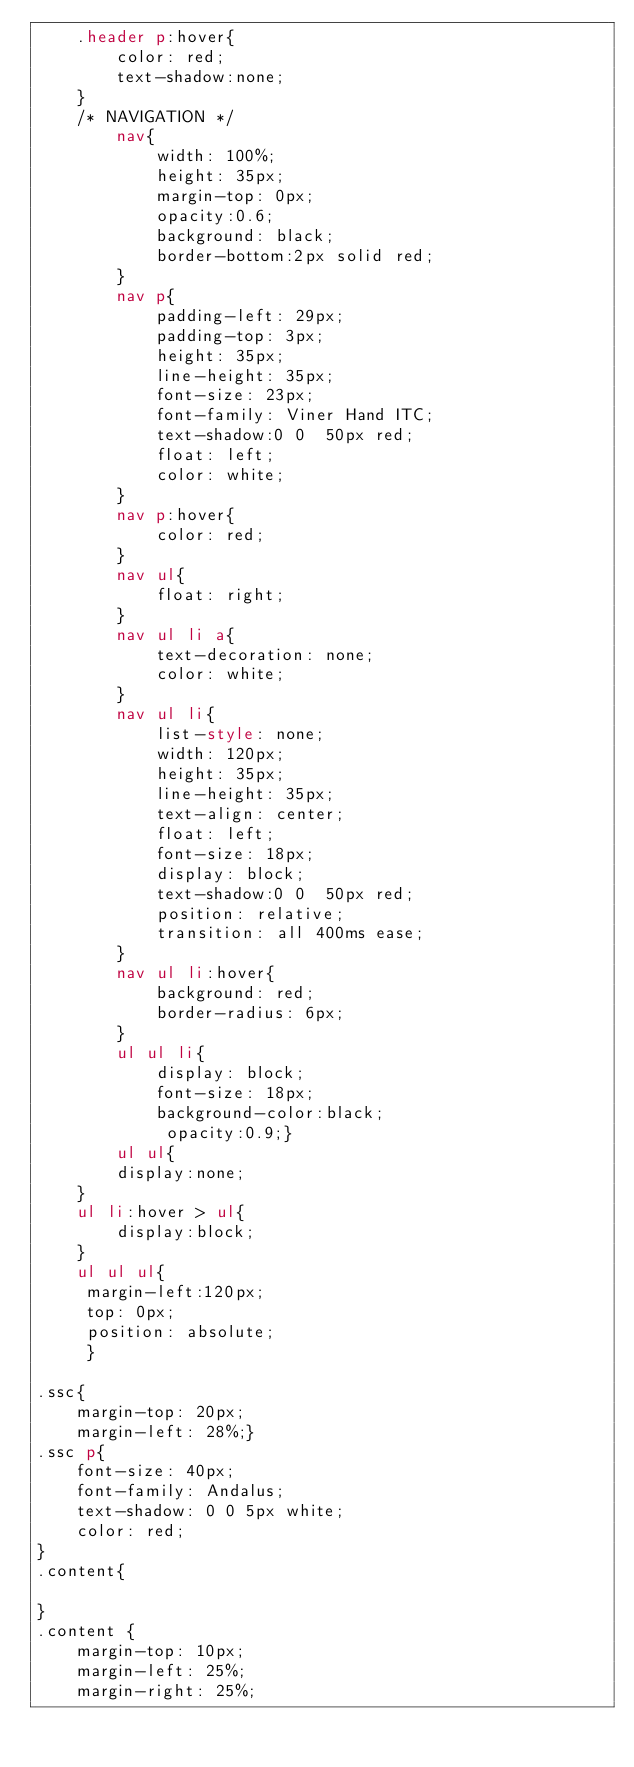<code> <loc_0><loc_0><loc_500><loc_500><_HTML_>	.header p:hover{
		color: red;
		text-shadow:none;
	}
	/* NAVIGATION */
		nav{
			width: 100%;
			height: 35px;
			margin-top: 0px;
			opacity:0.6;
			background: black;
			border-bottom:2px solid red;
		}
		nav p{
			padding-left: 29px;
			padding-top: 3px;
			height: 35px;
			line-height: 35px;
			font-size: 23px;
			font-family: Viner Hand ITC;
			text-shadow:0 0  50px red;
			float: left;
			color: white;
		}
		nav p:hover{
			color: red;
		}
		nav ul{
			float: right;
		}
		nav ul li a{
			text-decoration: none;
			color: white;
		}
		nav ul li{
			list-style: none;
			width: 120px;
			height: 35px;
			line-height: 35px;
			text-align: center;
			float: left;
			font-size: 18px;
			display: block;
			text-shadow:0 0  50px red;
			position: relative;
			transition: all 400ms ease;
		}
		nav ul li:hover{
			background: red;
			border-radius: 6px;
		}
        ul ul li{
        	display: block;
        	font-size: 18px;
        	background-color:black;
	         opacity:0.9;}
	    ul ul{
	    display:none;
	}
	ul li:hover > ul{
	    display:block;
	}
	ul ul ul{
	 margin-left:120px;
	 top: 0px;
	 position: absolute;
	 }

.ssc{
	margin-top: 20px;
	margin-left: 28%;}
.ssc p{
	font-size: 40px;
	font-family: Andalus;
	text-shadow: 0 0 5px white;
	color: red;
}
.content{

}
.content {
	margin-top: 10px;
	margin-left: 25%;
	margin-right: 25%;</code> 